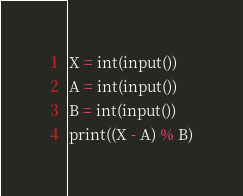Convert code to text. <code><loc_0><loc_0><loc_500><loc_500><_Python_>X = int(input())
A = int(input())
B = int(input())
print((X - A) % B)
</code> 